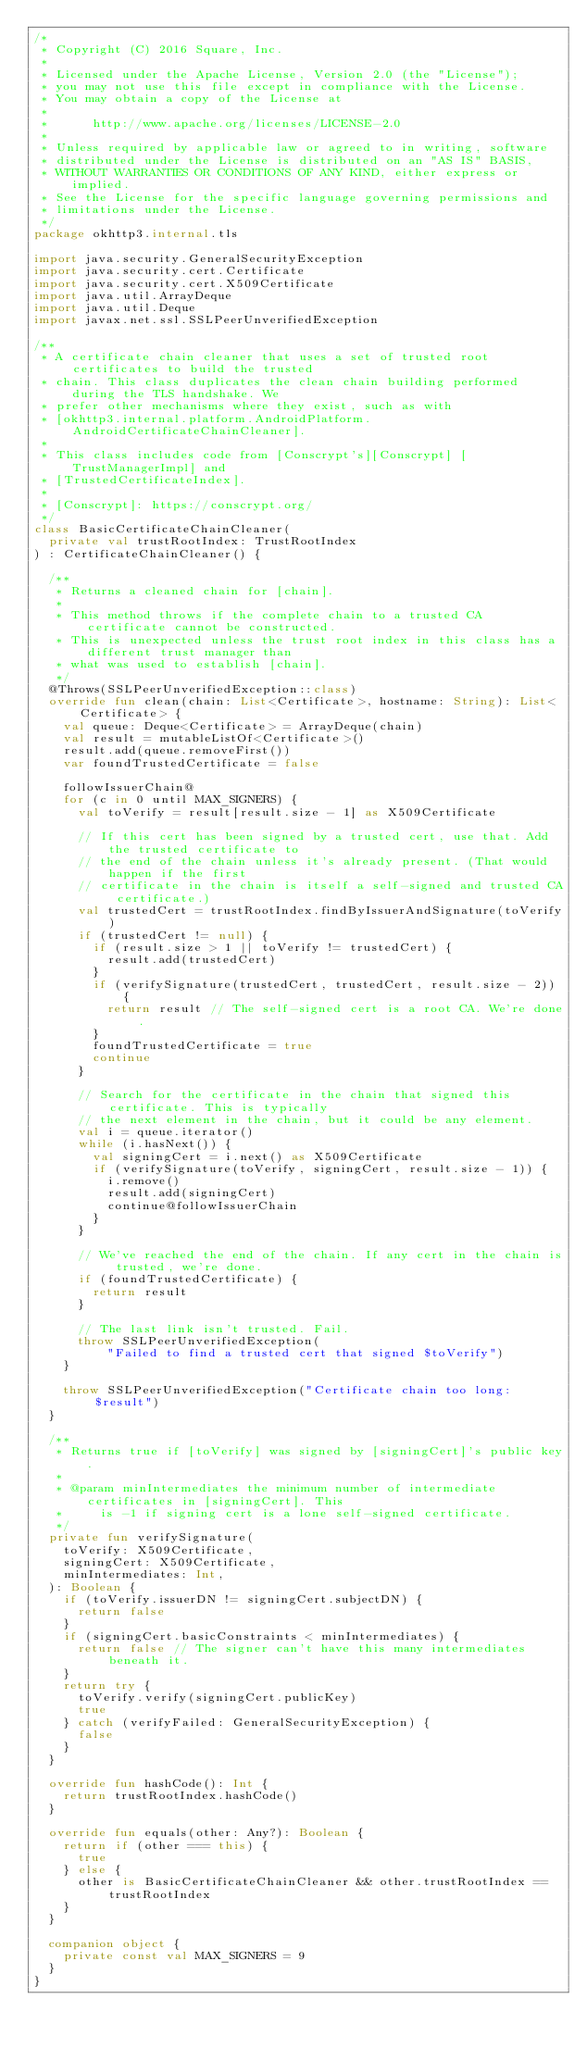Convert code to text. <code><loc_0><loc_0><loc_500><loc_500><_Kotlin_>/*
 * Copyright (C) 2016 Square, Inc.
 *
 * Licensed under the Apache License, Version 2.0 (the "License");
 * you may not use this file except in compliance with the License.
 * You may obtain a copy of the License at
 *
 *      http://www.apache.org/licenses/LICENSE-2.0
 *
 * Unless required by applicable law or agreed to in writing, software
 * distributed under the License is distributed on an "AS IS" BASIS,
 * WITHOUT WARRANTIES OR CONDITIONS OF ANY KIND, either express or implied.
 * See the License for the specific language governing permissions and
 * limitations under the License.
 */
package okhttp3.internal.tls

import java.security.GeneralSecurityException
import java.security.cert.Certificate
import java.security.cert.X509Certificate
import java.util.ArrayDeque
import java.util.Deque
import javax.net.ssl.SSLPeerUnverifiedException

/**
 * A certificate chain cleaner that uses a set of trusted root certificates to build the trusted
 * chain. This class duplicates the clean chain building performed during the TLS handshake. We
 * prefer other mechanisms where they exist, such as with
 * [okhttp3.internal.platform.AndroidPlatform.AndroidCertificateChainCleaner].
 *
 * This class includes code from [Conscrypt's][Conscrypt] [TrustManagerImpl] and
 * [TrustedCertificateIndex].
 *
 * [Conscrypt]: https://conscrypt.org/
 */
class BasicCertificateChainCleaner(
  private val trustRootIndex: TrustRootIndex
) : CertificateChainCleaner() {

  /**
   * Returns a cleaned chain for [chain].
   *
   * This method throws if the complete chain to a trusted CA certificate cannot be constructed.
   * This is unexpected unless the trust root index in this class has a different trust manager than
   * what was used to establish [chain].
   */
  @Throws(SSLPeerUnverifiedException::class)
  override fun clean(chain: List<Certificate>, hostname: String): List<Certificate> {
    val queue: Deque<Certificate> = ArrayDeque(chain)
    val result = mutableListOf<Certificate>()
    result.add(queue.removeFirst())
    var foundTrustedCertificate = false

    followIssuerChain@
    for (c in 0 until MAX_SIGNERS) {
      val toVerify = result[result.size - 1] as X509Certificate

      // If this cert has been signed by a trusted cert, use that. Add the trusted certificate to
      // the end of the chain unless it's already present. (That would happen if the first
      // certificate in the chain is itself a self-signed and trusted CA certificate.)
      val trustedCert = trustRootIndex.findByIssuerAndSignature(toVerify)
      if (trustedCert != null) {
        if (result.size > 1 || toVerify != trustedCert) {
          result.add(trustedCert)
        }
        if (verifySignature(trustedCert, trustedCert, result.size - 2)) {
          return result // The self-signed cert is a root CA. We're done.
        }
        foundTrustedCertificate = true
        continue
      }

      // Search for the certificate in the chain that signed this certificate. This is typically
      // the next element in the chain, but it could be any element.
      val i = queue.iterator()
      while (i.hasNext()) {
        val signingCert = i.next() as X509Certificate
        if (verifySignature(toVerify, signingCert, result.size - 1)) {
          i.remove()
          result.add(signingCert)
          continue@followIssuerChain
        }
      }

      // We've reached the end of the chain. If any cert in the chain is trusted, we're done.
      if (foundTrustedCertificate) {
        return result
      }

      // The last link isn't trusted. Fail.
      throw SSLPeerUnverifiedException(
          "Failed to find a trusted cert that signed $toVerify")
    }

    throw SSLPeerUnverifiedException("Certificate chain too long: $result")
  }

  /**
   * Returns true if [toVerify] was signed by [signingCert]'s public key.
   *
   * @param minIntermediates the minimum number of intermediate certificates in [signingCert]. This
   *     is -1 if signing cert is a lone self-signed certificate.
   */
  private fun verifySignature(
    toVerify: X509Certificate,
    signingCert: X509Certificate,
    minIntermediates: Int,
  ): Boolean {
    if (toVerify.issuerDN != signingCert.subjectDN) {
      return false
    }
    if (signingCert.basicConstraints < minIntermediates) {
      return false // The signer can't have this many intermediates beneath it.
    }
    return try {
      toVerify.verify(signingCert.publicKey)
      true
    } catch (verifyFailed: GeneralSecurityException) {
      false
    }
  }

  override fun hashCode(): Int {
    return trustRootIndex.hashCode()
  }

  override fun equals(other: Any?): Boolean {
    return if (other === this) {
      true
    } else {
      other is BasicCertificateChainCleaner && other.trustRootIndex == trustRootIndex
    }
  }

  companion object {
    private const val MAX_SIGNERS = 9
  }
}
</code> 